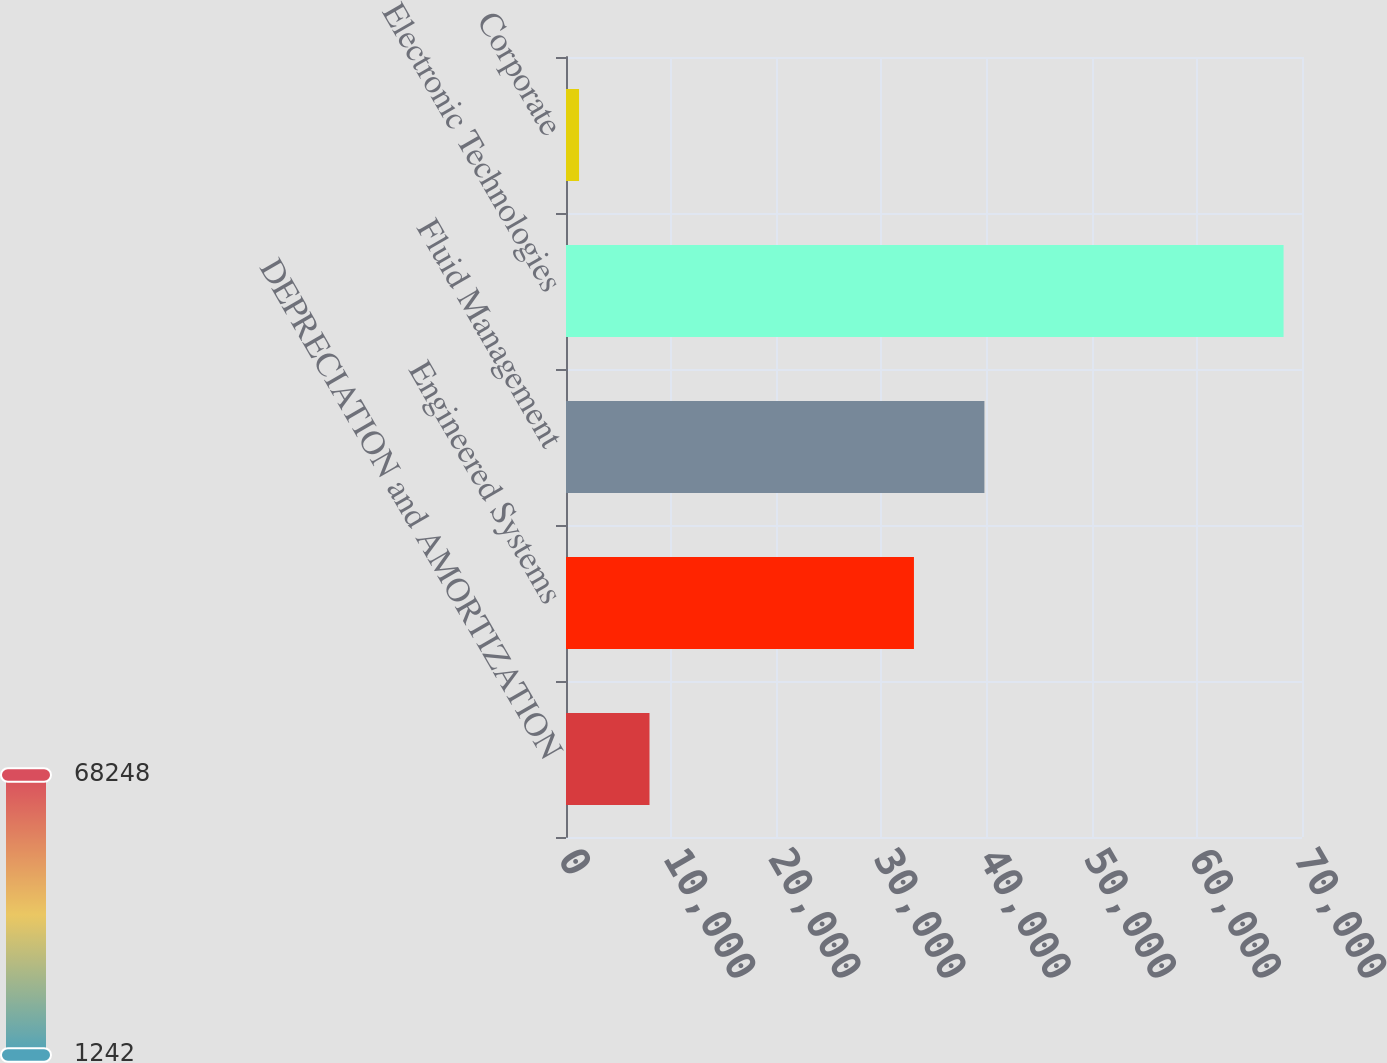<chart> <loc_0><loc_0><loc_500><loc_500><bar_chart><fcel>DEPRECIATION and AMORTIZATION<fcel>Engineered Systems<fcel>Fluid Management<fcel>Electronic Technologies<fcel>Corporate<nl><fcel>7942.6<fcel>33093<fcel>39793.6<fcel>68248<fcel>1242<nl></chart> 